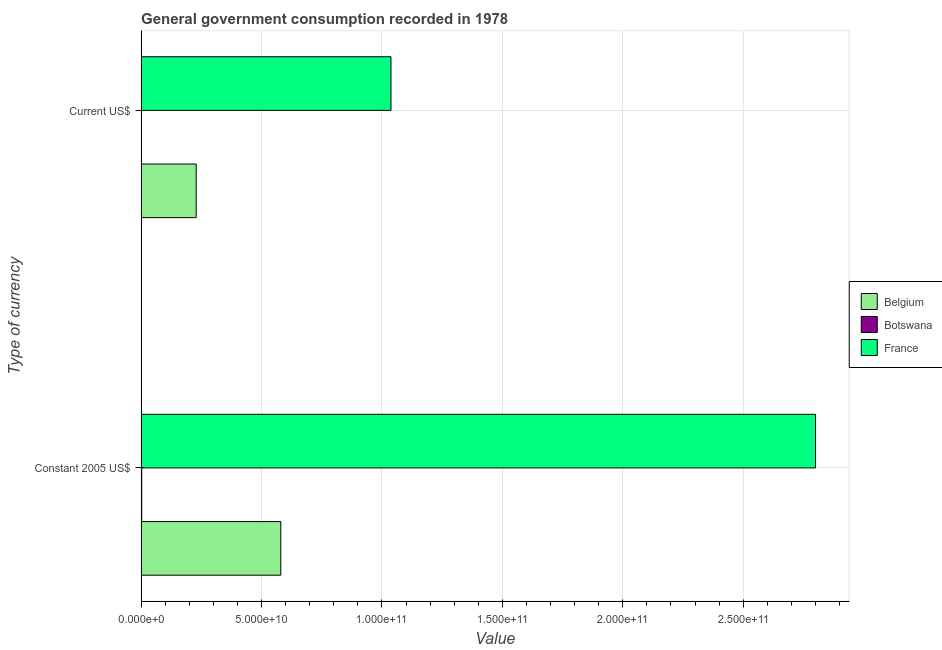How many groups of bars are there?
Give a very brief answer. 2. Are the number of bars per tick equal to the number of legend labels?
Offer a terse response. Yes. Are the number of bars on each tick of the Y-axis equal?
Your response must be concise. Yes. How many bars are there on the 2nd tick from the top?
Ensure brevity in your answer.  3. What is the label of the 2nd group of bars from the top?
Provide a succinct answer. Constant 2005 US$. What is the value consumed in constant 2005 us$ in Belgium?
Your answer should be compact. 5.80e+1. Across all countries, what is the maximum value consumed in current us$?
Ensure brevity in your answer.  1.04e+11. Across all countries, what is the minimum value consumed in constant 2005 us$?
Your response must be concise. 2.37e+08. In which country was the value consumed in constant 2005 us$ maximum?
Ensure brevity in your answer.  France. In which country was the value consumed in constant 2005 us$ minimum?
Provide a succinct answer. Botswana. What is the total value consumed in constant 2005 us$ in the graph?
Make the answer very short. 3.38e+11. What is the difference between the value consumed in current us$ in Botswana and that in France?
Provide a succinct answer. -1.04e+11. What is the difference between the value consumed in constant 2005 us$ in Belgium and the value consumed in current us$ in France?
Offer a terse response. -4.57e+1. What is the average value consumed in constant 2005 us$ per country?
Offer a terse response. 1.13e+11. What is the difference between the value consumed in constant 2005 us$ and value consumed in current us$ in Belgium?
Provide a short and direct response. 3.51e+1. What is the ratio of the value consumed in current us$ in Botswana to that in France?
Provide a short and direct response. 0. Is the value consumed in constant 2005 us$ in Belgium less than that in Botswana?
Your answer should be very brief. No. What does the 3rd bar from the top in Current US$ represents?
Keep it short and to the point. Belgium. What does the 3rd bar from the bottom in Constant 2005 US$ represents?
Your response must be concise. France. What is the difference between two consecutive major ticks on the X-axis?
Offer a very short reply. 5.00e+1. Does the graph contain any zero values?
Give a very brief answer. No. Where does the legend appear in the graph?
Offer a very short reply. Center right. How are the legend labels stacked?
Offer a terse response. Vertical. What is the title of the graph?
Keep it short and to the point. General government consumption recorded in 1978. What is the label or title of the X-axis?
Your answer should be very brief. Value. What is the label or title of the Y-axis?
Your answer should be compact. Type of currency. What is the Value of Belgium in Constant 2005 US$?
Your response must be concise. 5.80e+1. What is the Value of Botswana in Constant 2005 US$?
Make the answer very short. 2.37e+08. What is the Value of France in Constant 2005 US$?
Your answer should be very brief. 2.80e+11. What is the Value of Belgium in Current US$?
Offer a very short reply. 2.29e+1. What is the Value in Botswana in Current US$?
Offer a very short reply. 1.25e+08. What is the Value of France in Current US$?
Ensure brevity in your answer.  1.04e+11. Across all Type of currency, what is the maximum Value in Belgium?
Give a very brief answer. 5.80e+1. Across all Type of currency, what is the maximum Value of Botswana?
Ensure brevity in your answer.  2.37e+08. Across all Type of currency, what is the maximum Value in France?
Your response must be concise. 2.80e+11. Across all Type of currency, what is the minimum Value of Belgium?
Provide a short and direct response. 2.29e+1. Across all Type of currency, what is the minimum Value in Botswana?
Make the answer very short. 1.25e+08. Across all Type of currency, what is the minimum Value in France?
Give a very brief answer. 1.04e+11. What is the total Value in Belgium in the graph?
Give a very brief answer. 8.08e+1. What is the total Value of Botswana in the graph?
Offer a very short reply. 3.62e+08. What is the total Value in France in the graph?
Your response must be concise. 3.84e+11. What is the difference between the Value in Belgium in Constant 2005 US$ and that in Current US$?
Your answer should be compact. 3.51e+1. What is the difference between the Value in Botswana in Constant 2005 US$ and that in Current US$?
Your answer should be compact. 1.13e+08. What is the difference between the Value of France in Constant 2005 US$ and that in Current US$?
Offer a very short reply. 1.76e+11. What is the difference between the Value of Belgium in Constant 2005 US$ and the Value of Botswana in Current US$?
Give a very brief answer. 5.79e+1. What is the difference between the Value of Belgium in Constant 2005 US$ and the Value of France in Current US$?
Your answer should be compact. -4.57e+1. What is the difference between the Value in Botswana in Constant 2005 US$ and the Value in France in Current US$?
Give a very brief answer. -1.04e+11. What is the average Value of Belgium per Type of currency?
Your answer should be very brief. 4.04e+1. What is the average Value of Botswana per Type of currency?
Keep it short and to the point. 1.81e+08. What is the average Value of France per Type of currency?
Keep it short and to the point. 1.92e+11. What is the difference between the Value in Belgium and Value in Botswana in Constant 2005 US$?
Offer a terse response. 5.78e+1. What is the difference between the Value in Belgium and Value in France in Constant 2005 US$?
Make the answer very short. -2.22e+11. What is the difference between the Value of Botswana and Value of France in Constant 2005 US$?
Offer a very short reply. -2.80e+11. What is the difference between the Value in Belgium and Value in Botswana in Current US$?
Make the answer very short. 2.27e+1. What is the difference between the Value in Belgium and Value in France in Current US$?
Make the answer very short. -8.09e+1. What is the difference between the Value of Botswana and Value of France in Current US$?
Keep it short and to the point. -1.04e+11. What is the ratio of the Value of Belgium in Constant 2005 US$ to that in Current US$?
Your answer should be very brief. 2.54. What is the ratio of the Value in Botswana in Constant 2005 US$ to that in Current US$?
Provide a short and direct response. 1.9. What is the ratio of the Value in France in Constant 2005 US$ to that in Current US$?
Offer a terse response. 2.7. What is the difference between the highest and the second highest Value of Belgium?
Your answer should be compact. 3.51e+1. What is the difference between the highest and the second highest Value in Botswana?
Your answer should be compact. 1.13e+08. What is the difference between the highest and the second highest Value of France?
Your response must be concise. 1.76e+11. What is the difference between the highest and the lowest Value of Belgium?
Ensure brevity in your answer.  3.51e+1. What is the difference between the highest and the lowest Value of Botswana?
Your answer should be very brief. 1.13e+08. What is the difference between the highest and the lowest Value in France?
Your answer should be compact. 1.76e+11. 